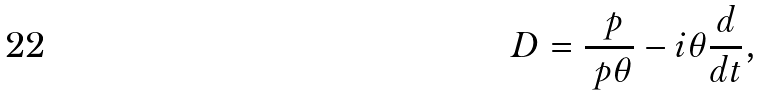<formula> <loc_0><loc_0><loc_500><loc_500>D = \frac { \ p } { \ p \theta } - i \theta \frac { d } { d t } ,</formula> 